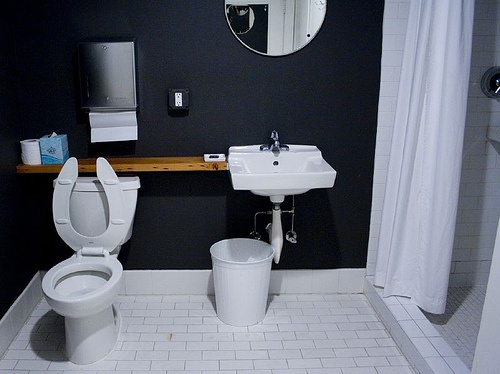Describe the objects in this image and their specific colors. I can see toilet in black, darkgray, lightgray, and gray tones and sink in black, lightgray, and darkgray tones in this image. 